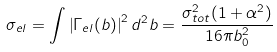<formula> <loc_0><loc_0><loc_500><loc_500>\sigma _ { e l } = \int \left | \Gamma _ { e l } ( { b } ) \right | ^ { 2 } d ^ { 2 } b = \frac { \sigma _ { t o t } ^ { 2 } ( 1 + \alpha ^ { 2 } ) } { 1 6 \pi b _ { 0 } ^ { 2 } }</formula> 